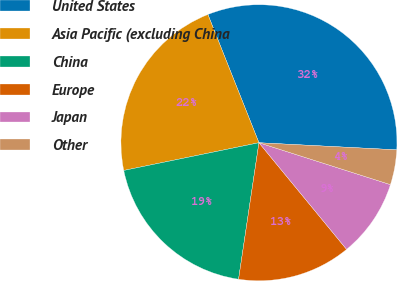<chart> <loc_0><loc_0><loc_500><loc_500><pie_chart><fcel>United States<fcel>Asia Pacific (excluding China<fcel>China<fcel>Europe<fcel>Japan<fcel>Other<nl><fcel>31.85%<fcel>22.19%<fcel>19.42%<fcel>13.31%<fcel>9.14%<fcel>4.09%<nl></chart> 